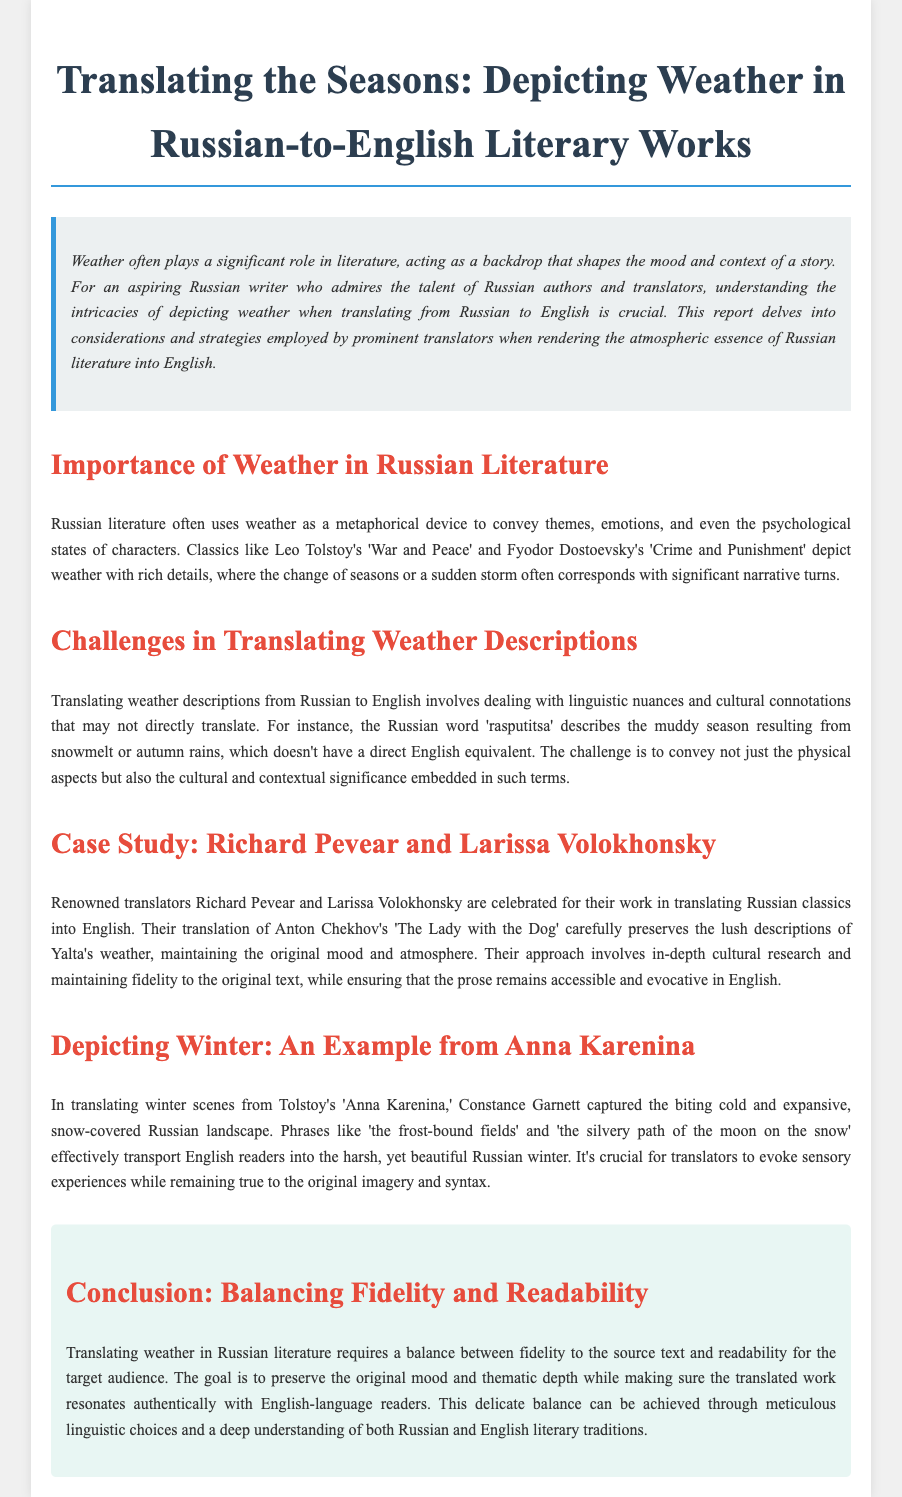what is the title of the document? The title of the document is presented prominently at the top of the content.
Answer: Translating the Seasons: Depicting Weather in Russian-to-English Literary Works who are the renowned translators mentioned in the case study? The document explicitly names the translators who are consulted as examples in the case study.
Answer: Richard Pevear and Larissa Volokhonsky what is the primary challenge in translating weather descriptions? The document identifies key issues faced in the translation process concerning weather descriptions and nuances.
Answer: Linguistic nuances and cultural connotations which Russian author's work is referenced in depicting winter scenes? Referencing specific authors helps grasp their significance in the context of weather descriptions in literature.
Answer: Leo Tolstoy what is the cultural term in Russian that refers to the muddy season? This question addresses specific terms that highlight the nuances in language and culture.
Answer: rasputitsa what does the conclusion emphasize regarding translation? The conclusion summarizes core insights regarding translation practices and their impact.
Answer: Balancing fidelity and readability what season is primarily depicted in Tolstoy's 'Anna Karenina'? The document focuses specifically on seasonal depictions relevant to the examples given.
Answer: Winter how does weather function in Russian literature according to the document? Understanding the document's portrayal of weather in literary context helps answer this.
Answer: As a metaphorical device 